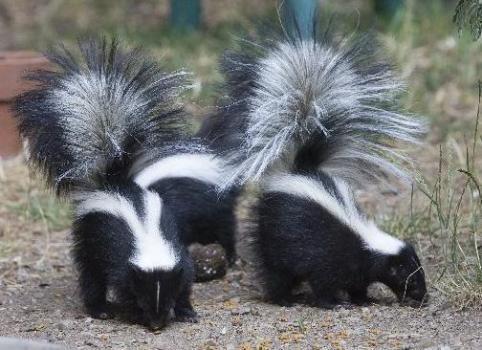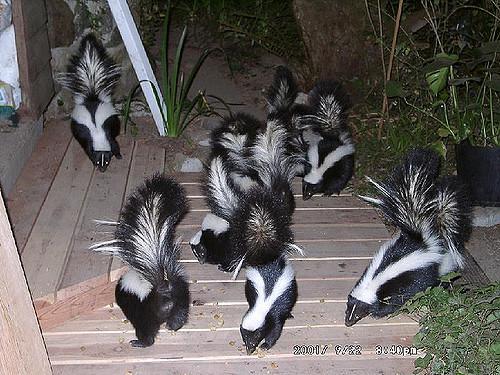The first image is the image on the left, the second image is the image on the right. Examine the images to the left and right. Is the description "At least one skunk is eating." accurate? Answer yes or no. Yes. 